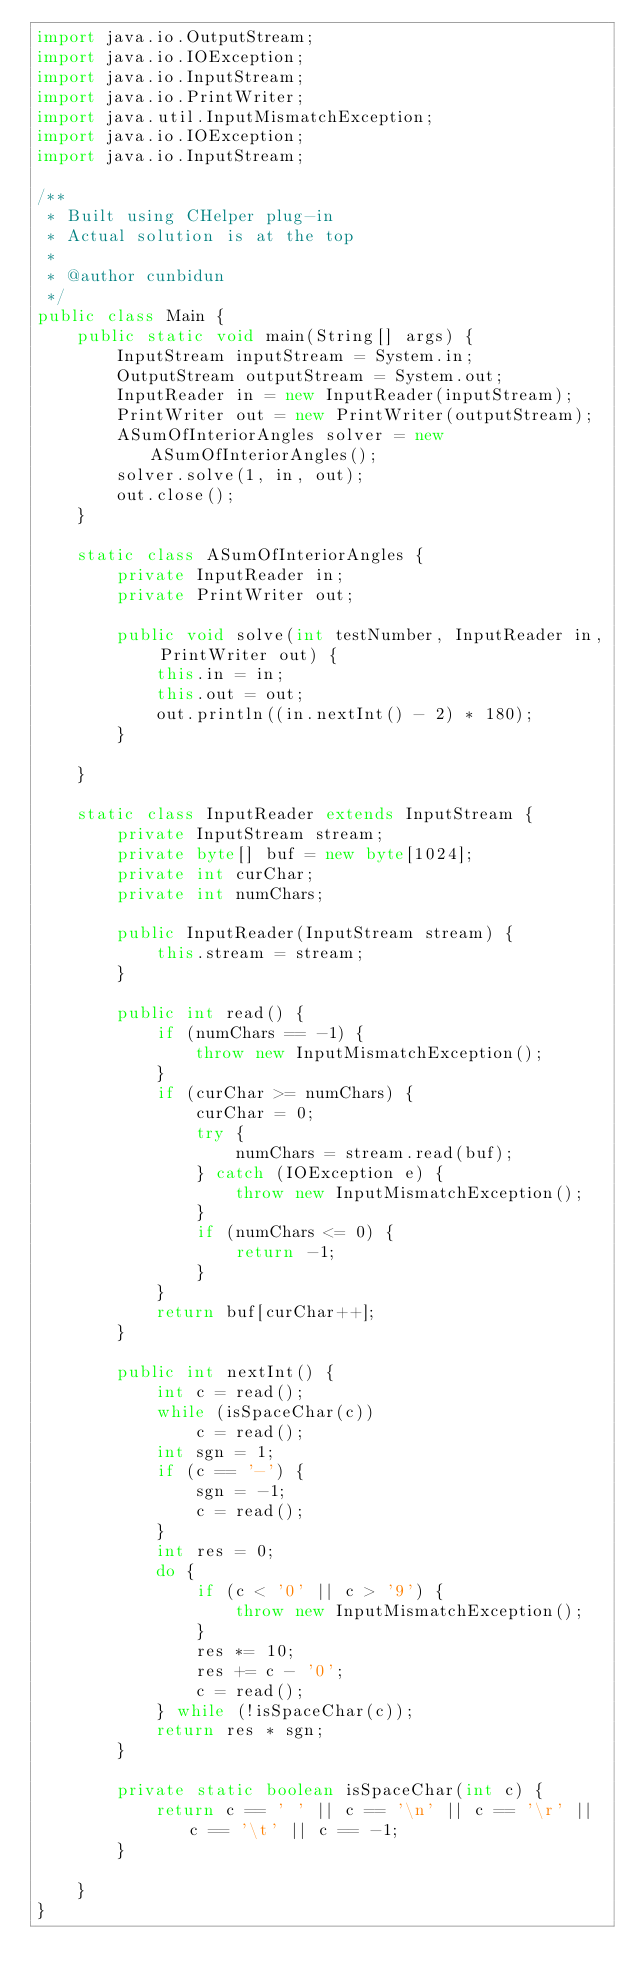Convert code to text. <code><loc_0><loc_0><loc_500><loc_500><_Java_>import java.io.OutputStream;
import java.io.IOException;
import java.io.InputStream;
import java.io.PrintWriter;
import java.util.InputMismatchException;
import java.io.IOException;
import java.io.InputStream;

/**
 * Built using CHelper plug-in
 * Actual solution is at the top
 *
 * @author cunbidun
 */
public class Main {
    public static void main(String[] args) {
        InputStream inputStream = System.in;
        OutputStream outputStream = System.out;
        InputReader in = new InputReader(inputStream);
        PrintWriter out = new PrintWriter(outputStream);
        ASumOfInteriorAngles solver = new ASumOfInteriorAngles();
        solver.solve(1, in, out);
        out.close();
    }

    static class ASumOfInteriorAngles {
        private InputReader in;
        private PrintWriter out;

        public void solve(int testNumber, InputReader in, PrintWriter out) {
            this.in = in;
            this.out = out;
            out.println((in.nextInt() - 2) * 180);
        }

    }

    static class InputReader extends InputStream {
        private InputStream stream;
        private byte[] buf = new byte[1024];
        private int curChar;
        private int numChars;

        public InputReader(InputStream stream) {
            this.stream = stream;
        }

        public int read() {
            if (numChars == -1) {
                throw new InputMismatchException();
            }
            if (curChar >= numChars) {
                curChar = 0;
                try {
                    numChars = stream.read(buf);
                } catch (IOException e) {
                    throw new InputMismatchException();
                }
                if (numChars <= 0) {
                    return -1;
                }
            }
            return buf[curChar++];
        }

        public int nextInt() {
            int c = read();
            while (isSpaceChar(c))
                c = read();
            int sgn = 1;
            if (c == '-') {
                sgn = -1;
                c = read();
            }
            int res = 0;
            do {
                if (c < '0' || c > '9') {
                    throw new InputMismatchException();
                }
                res *= 10;
                res += c - '0';
                c = read();
            } while (!isSpaceChar(c));
            return res * sgn;
        }

        private static boolean isSpaceChar(int c) {
            return c == ' ' || c == '\n' || c == '\r' || c == '\t' || c == -1;
        }

    }
}

</code> 